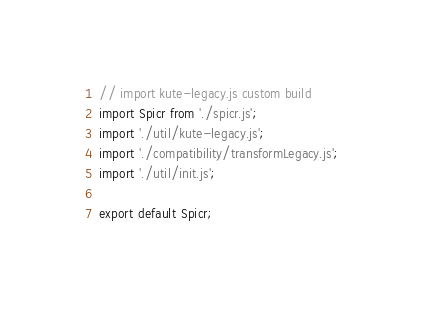<code> <loc_0><loc_0><loc_500><loc_500><_JavaScript_>// import kute-legacy.js custom build
import Spicr from './spicr.js';
import './util/kute-legacy.js';
import './compatibility/transformLegacy.js';
import './util/init.js';

export default Spicr;
</code> 